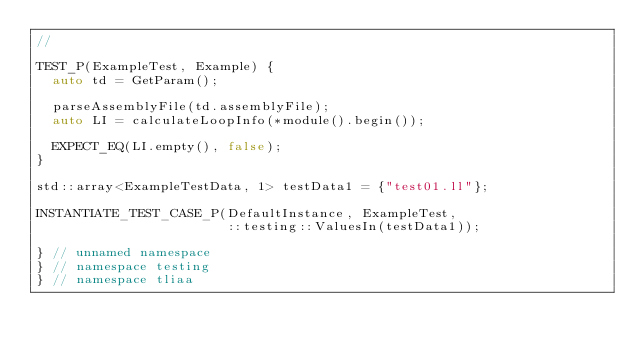Convert code to text. <code><loc_0><loc_0><loc_500><loc_500><_C++_>//

TEST_P(ExampleTest, Example) {
  auto td = GetParam();

  parseAssemblyFile(td.assemblyFile);
  auto LI = calculateLoopInfo(*module().begin());

  EXPECT_EQ(LI.empty(), false);
}

std::array<ExampleTestData, 1> testData1 = {"test01.ll"};

INSTANTIATE_TEST_CASE_P(DefaultInstance, ExampleTest,
                        ::testing::ValuesIn(testData1));

} // unnamed namespace
} // namespace testing
} // namespace tliaa
</code> 